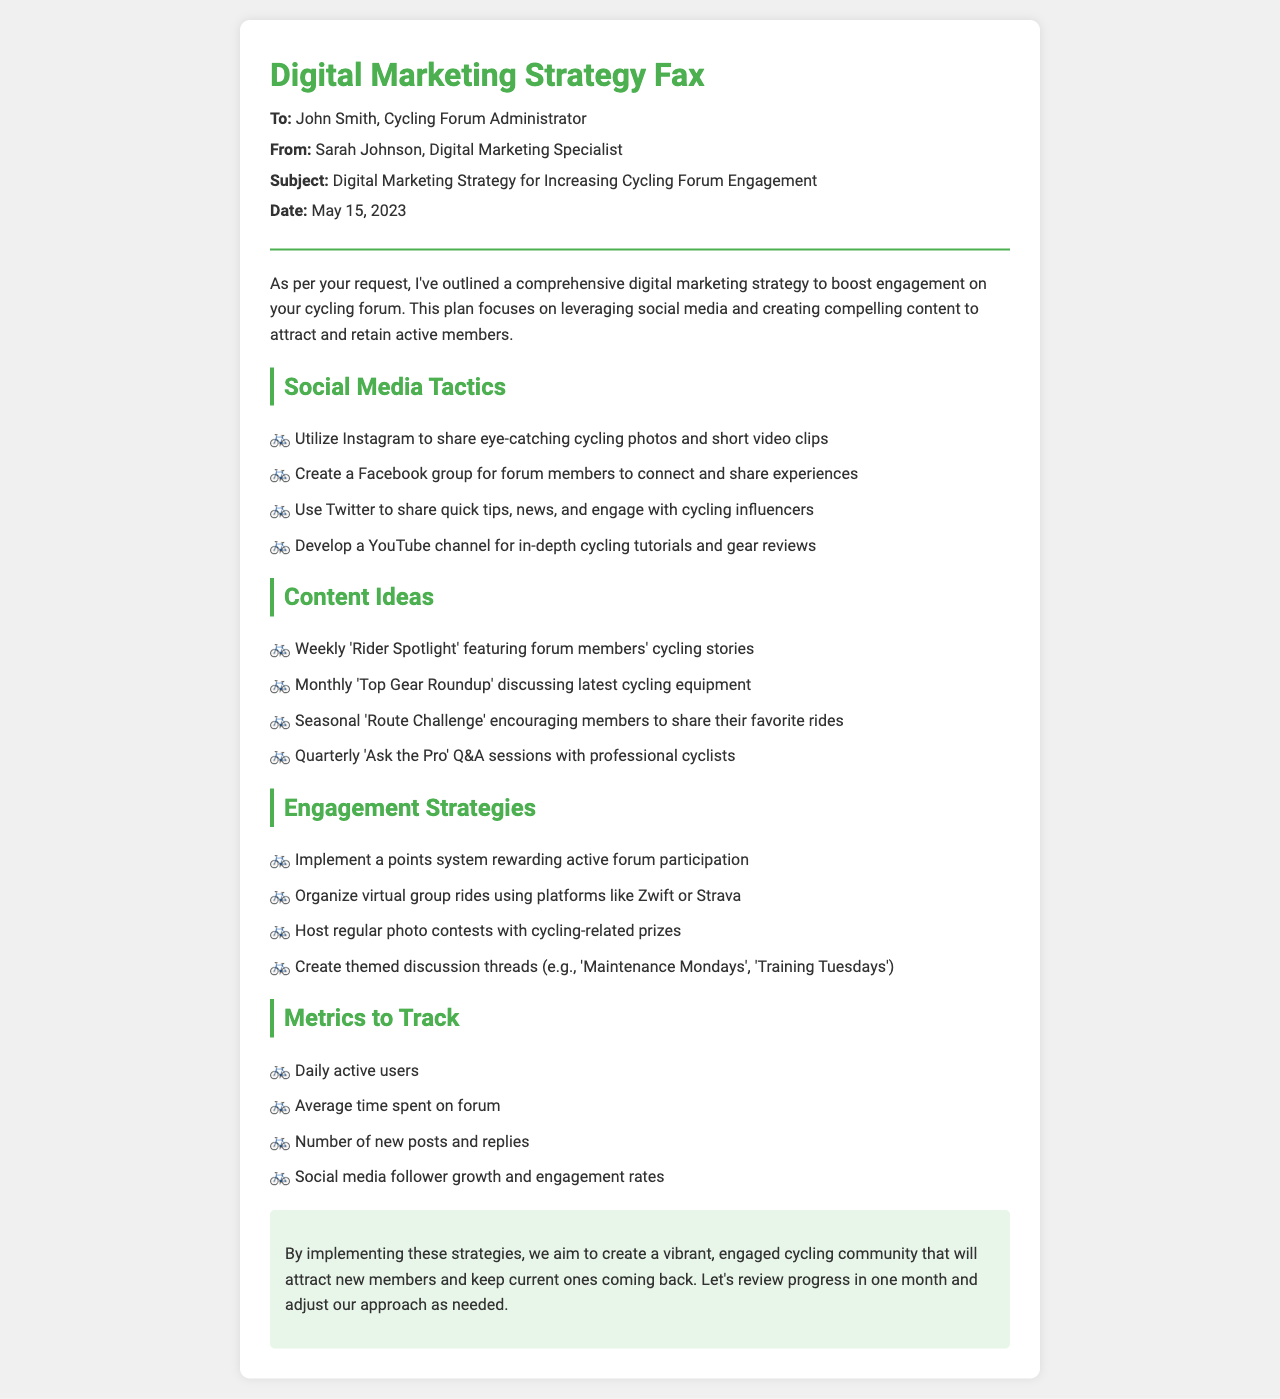What is the sender's name? The sender's name is Sarah Johnson, as stated at the top of the fax under 'From'.
Answer: Sarah Johnson What is the date of the fax? The date is mentioned in the introductory section of the fax.
Answer: May 15, 2023 What social media platform is suggested for sharing cycling photos? The platform for photos is specifically mentioned in the social media tactics section.
Answer: Instagram What type of contest is proposed for member engagement? The type of contest can be found in the engagement strategies section of the fax.
Answer: Photo contests How often is the 'Rider Spotlight' feature planned to be published? The frequency of the 'Rider Spotlight' can be inferred from the content ideas section.
Answer: Weekly Which digital marketing strategy involves professional cyclists? This involves a specific Q&A session mentioned in the content ideas.
Answer: Ask the Pro What color is used in the header of the fax? The color is noted in the style elements applied to the header.
Answer: Green What metric is suggested to track the growth of social media followers? This metric is listed in the metrics to track section.
Answer: Follower growth 